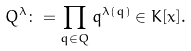<formula> <loc_0><loc_0><loc_500><loc_500>Q ^ { \lambda } \colon = \prod _ { q \in Q } q ^ { \lambda ( q ) } \in K [ x ] .</formula> 